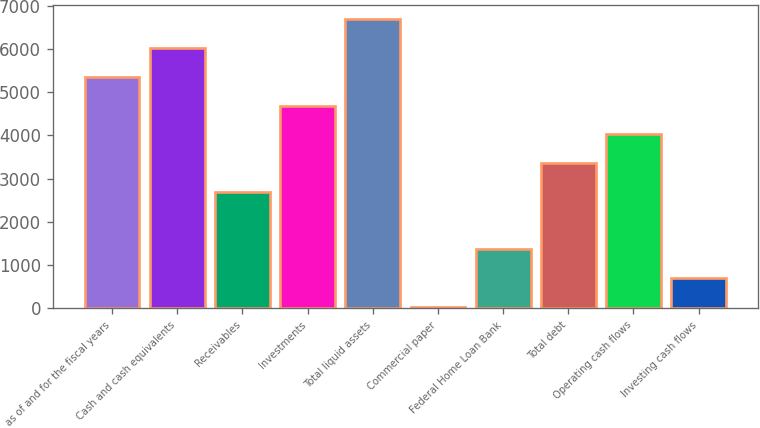<chart> <loc_0><loc_0><loc_500><loc_500><bar_chart><fcel>as of and for the fiscal years<fcel>Cash and cash equivalents<fcel>Receivables<fcel>Investments<fcel>Total liquid assets<fcel>Commercial paper<fcel>Federal Home Loan Bank<fcel>Total debt<fcel>Operating cash flows<fcel>Investing cash flows<nl><fcel>5353.28<fcel>6018.69<fcel>2691.64<fcel>4687.87<fcel>6684.1<fcel>30<fcel>1360.82<fcel>3357.05<fcel>4022.46<fcel>695.41<nl></chart> 